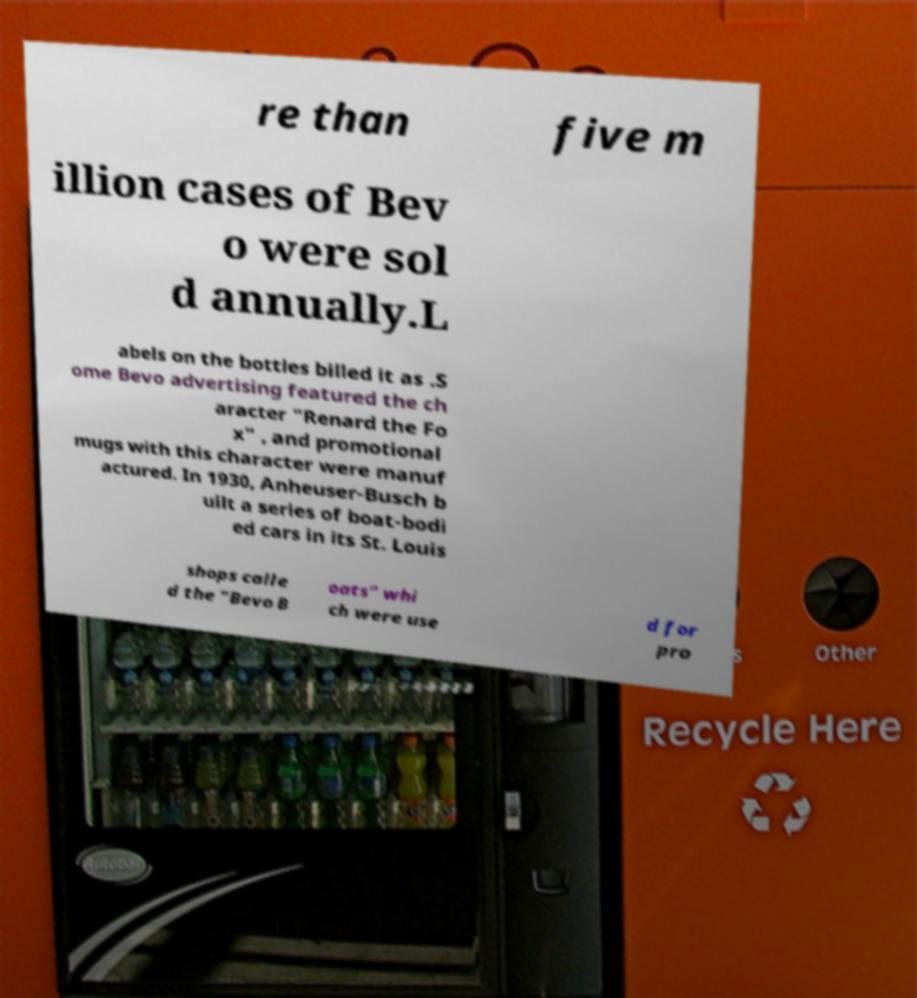Could you assist in decoding the text presented in this image and type it out clearly? re than five m illion cases of Bev o were sol d annually.L abels on the bottles billed it as .S ome Bevo advertising featured the ch aracter "Renard the Fo x" , and promotional mugs with this character were manuf actured. In 1930, Anheuser-Busch b uilt a series of boat-bodi ed cars in its St. Louis shops calle d the "Bevo B oats" whi ch were use d for pro 